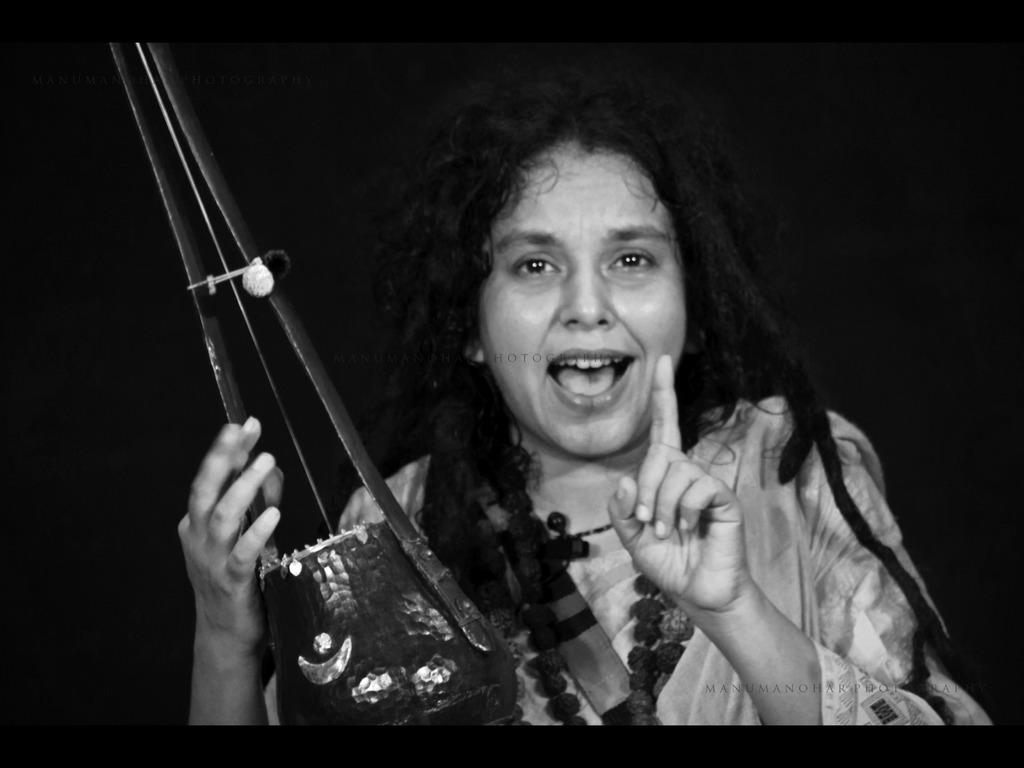Who is the main subject in the image? There is a lady in the image. Where is the lady positioned in the image? The lady is in the center of the image. What is the lady holding in her hand? The lady is holding a musical instrument in her hand. What type of needle is the lady using to sew in the image? There is no needle present in the image; the lady is holding a musical instrument. How many minutes does the lady spend playing the musical instrument in the image? The image does not provide information about the duration of the lady playing the musical instrument, so we cannot determine the number of minutes. 